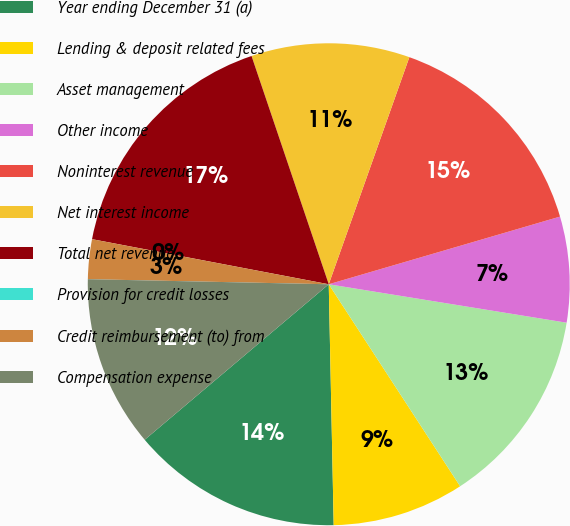Convert chart to OTSL. <chart><loc_0><loc_0><loc_500><loc_500><pie_chart><fcel>Year ending December 31 (a)<fcel>Lending & deposit related fees<fcel>Asset management<fcel>Other income<fcel>Noninterest revenue<fcel>Net interest income<fcel>Total net revenue<fcel>Provision for credit losses<fcel>Credit reimbursement (to) from<fcel>Compensation expense<nl><fcel>14.16%<fcel>8.85%<fcel>13.27%<fcel>7.08%<fcel>15.04%<fcel>10.62%<fcel>16.81%<fcel>0.0%<fcel>2.66%<fcel>11.5%<nl></chart> 